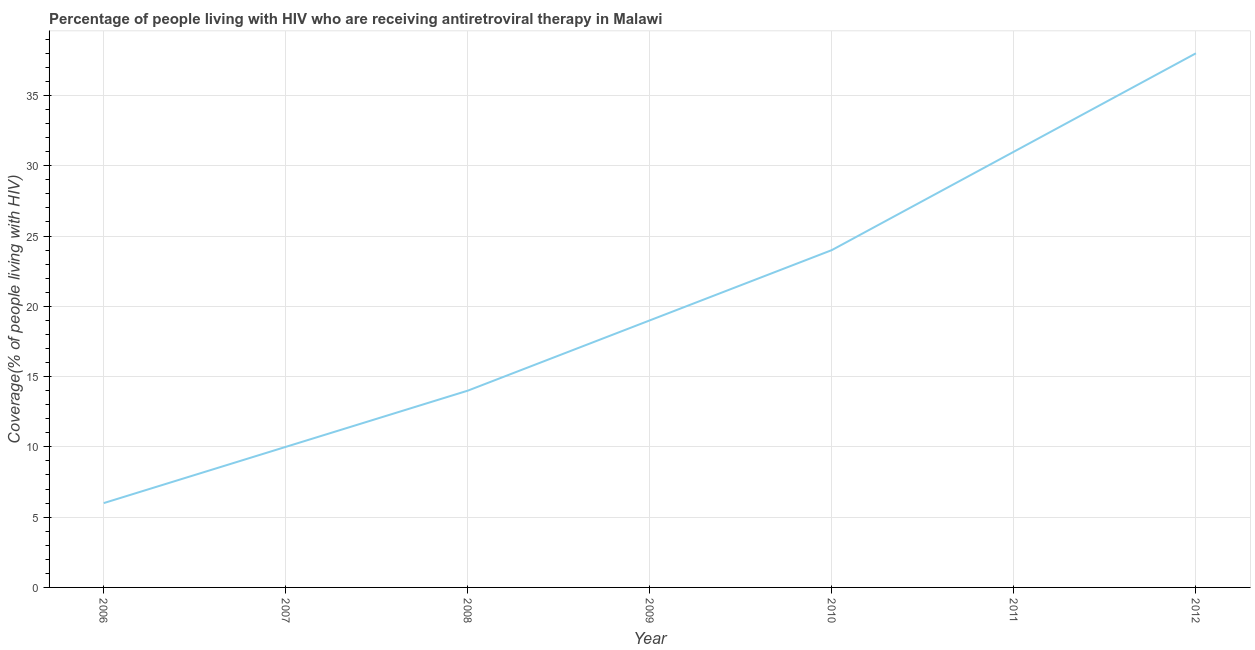What is the antiretroviral therapy coverage in 2011?
Offer a terse response. 31. Across all years, what is the maximum antiretroviral therapy coverage?
Give a very brief answer. 38. In which year was the antiretroviral therapy coverage minimum?
Your answer should be compact. 2006. What is the sum of the antiretroviral therapy coverage?
Provide a short and direct response. 142. What is the difference between the antiretroviral therapy coverage in 2007 and 2012?
Offer a very short reply. -28. What is the average antiretroviral therapy coverage per year?
Make the answer very short. 20.29. What is the median antiretroviral therapy coverage?
Provide a succinct answer. 19. Do a majority of the years between 2010 and 2008 (inclusive) have antiretroviral therapy coverage greater than 24 %?
Give a very brief answer. No. What is the ratio of the antiretroviral therapy coverage in 2008 to that in 2009?
Your answer should be compact. 0.74. Is the antiretroviral therapy coverage in 2006 less than that in 2012?
Your answer should be very brief. Yes. Is the sum of the antiretroviral therapy coverage in 2007 and 2008 greater than the maximum antiretroviral therapy coverage across all years?
Keep it short and to the point. No. What is the difference between the highest and the lowest antiretroviral therapy coverage?
Ensure brevity in your answer.  32. In how many years, is the antiretroviral therapy coverage greater than the average antiretroviral therapy coverage taken over all years?
Give a very brief answer. 3. Does the antiretroviral therapy coverage monotonically increase over the years?
Your response must be concise. Yes. How many lines are there?
Ensure brevity in your answer.  1. How many years are there in the graph?
Ensure brevity in your answer.  7. Are the values on the major ticks of Y-axis written in scientific E-notation?
Give a very brief answer. No. Does the graph contain any zero values?
Offer a terse response. No. What is the title of the graph?
Provide a short and direct response. Percentage of people living with HIV who are receiving antiretroviral therapy in Malawi. What is the label or title of the Y-axis?
Provide a short and direct response. Coverage(% of people living with HIV). What is the Coverage(% of people living with HIV) of 2006?
Offer a terse response. 6. What is the Coverage(% of people living with HIV) of 2007?
Make the answer very short. 10. What is the Coverage(% of people living with HIV) of 2009?
Provide a succinct answer. 19. What is the Coverage(% of people living with HIV) of 2010?
Offer a terse response. 24. What is the difference between the Coverage(% of people living with HIV) in 2006 and 2007?
Keep it short and to the point. -4. What is the difference between the Coverage(% of people living with HIV) in 2006 and 2009?
Give a very brief answer. -13. What is the difference between the Coverage(% of people living with HIV) in 2006 and 2012?
Your answer should be very brief. -32. What is the difference between the Coverage(% of people living with HIV) in 2007 and 2012?
Your answer should be very brief. -28. What is the difference between the Coverage(% of people living with HIV) in 2009 and 2010?
Keep it short and to the point. -5. What is the difference between the Coverage(% of people living with HIV) in 2009 and 2011?
Provide a succinct answer. -12. What is the difference between the Coverage(% of people living with HIV) in 2009 and 2012?
Offer a terse response. -19. What is the difference between the Coverage(% of people living with HIV) in 2010 and 2011?
Offer a terse response. -7. What is the difference between the Coverage(% of people living with HIV) in 2011 and 2012?
Your answer should be very brief. -7. What is the ratio of the Coverage(% of people living with HIV) in 2006 to that in 2008?
Your response must be concise. 0.43. What is the ratio of the Coverage(% of people living with HIV) in 2006 to that in 2009?
Ensure brevity in your answer.  0.32. What is the ratio of the Coverage(% of people living with HIV) in 2006 to that in 2011?
Provide a short and direct response. 0.19. What is the ratio of the Coverage(% of people living with HIV) in 2006 to that in 2012?
Your answer should be very brief. 0.16. What is the ratio of the Coverage(% of people living with HIV) in 2007 to that in 2008?
Your response must be concise. 0.71. What is the ratio of the Coverage(% of people living with HIV) in 2007 to that in 2009?
Your response must be concise. 0.53. What is the ratio of the Coverage(% of people living with HIV) in 2007 to that in 2010?
Provide a short and direct response. 0.42. What is the ratio of the Coverage(% of people living with HIV) in 2007 to that in 2011?
Offer a terse response. 0.32. What is the ratio of the Coverage(% of people living with HIV) in 2007 to that in 2012?
Your response must be concise. 0.26. What is the ratio of the Coverage(% of people living with HIV) in 2008 to that in 2009?
Your answer should be very brief. 0.74. What is the ratio of the Coverage(% of people living with HIV) in 2008 to that in 2010?
Provide a succinct answer. 0.58. What is the ratio of the Coverage(% of people living with HIV) in 2008 to that in 2011?
Offer a terse response. 0.45. What is the ratio of the Coverage(% of people living with HIV) in 2008 to that in 2012?
Ensure brevity in your answer.  0.37. What is the ratio of the Coverage(% of people living with HIV) in 2009 to that in 2010?
Provide a succinct answer. 0.79. What is the ratio of the Coverage(% of people living with HIV) in 2009 to that in 2011?
Your response must be concise. 0.61. What is the ratio of the Coverage(% of people living with HIV) in 2009 to that in 2012?
Make the answer very short. 0.5. What is the ratio of the Coverage(% of people living with HIV) in 2010 to that in 2011?
Provide a succinct answer. 0.77. What is the ratio of the Coverage(% of people living with HIV) in 2010 to that in 2012?
Make the answer very short. 0.63. What is the ratio of the Coverage(% of people living with HIV) in 2011 to that in 2012?
Ensure brevity in your answer.  0.82. 